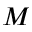Convert formula to latex. <formula><loc_0><loc_0><loc_500><loc_500>M</formula> 